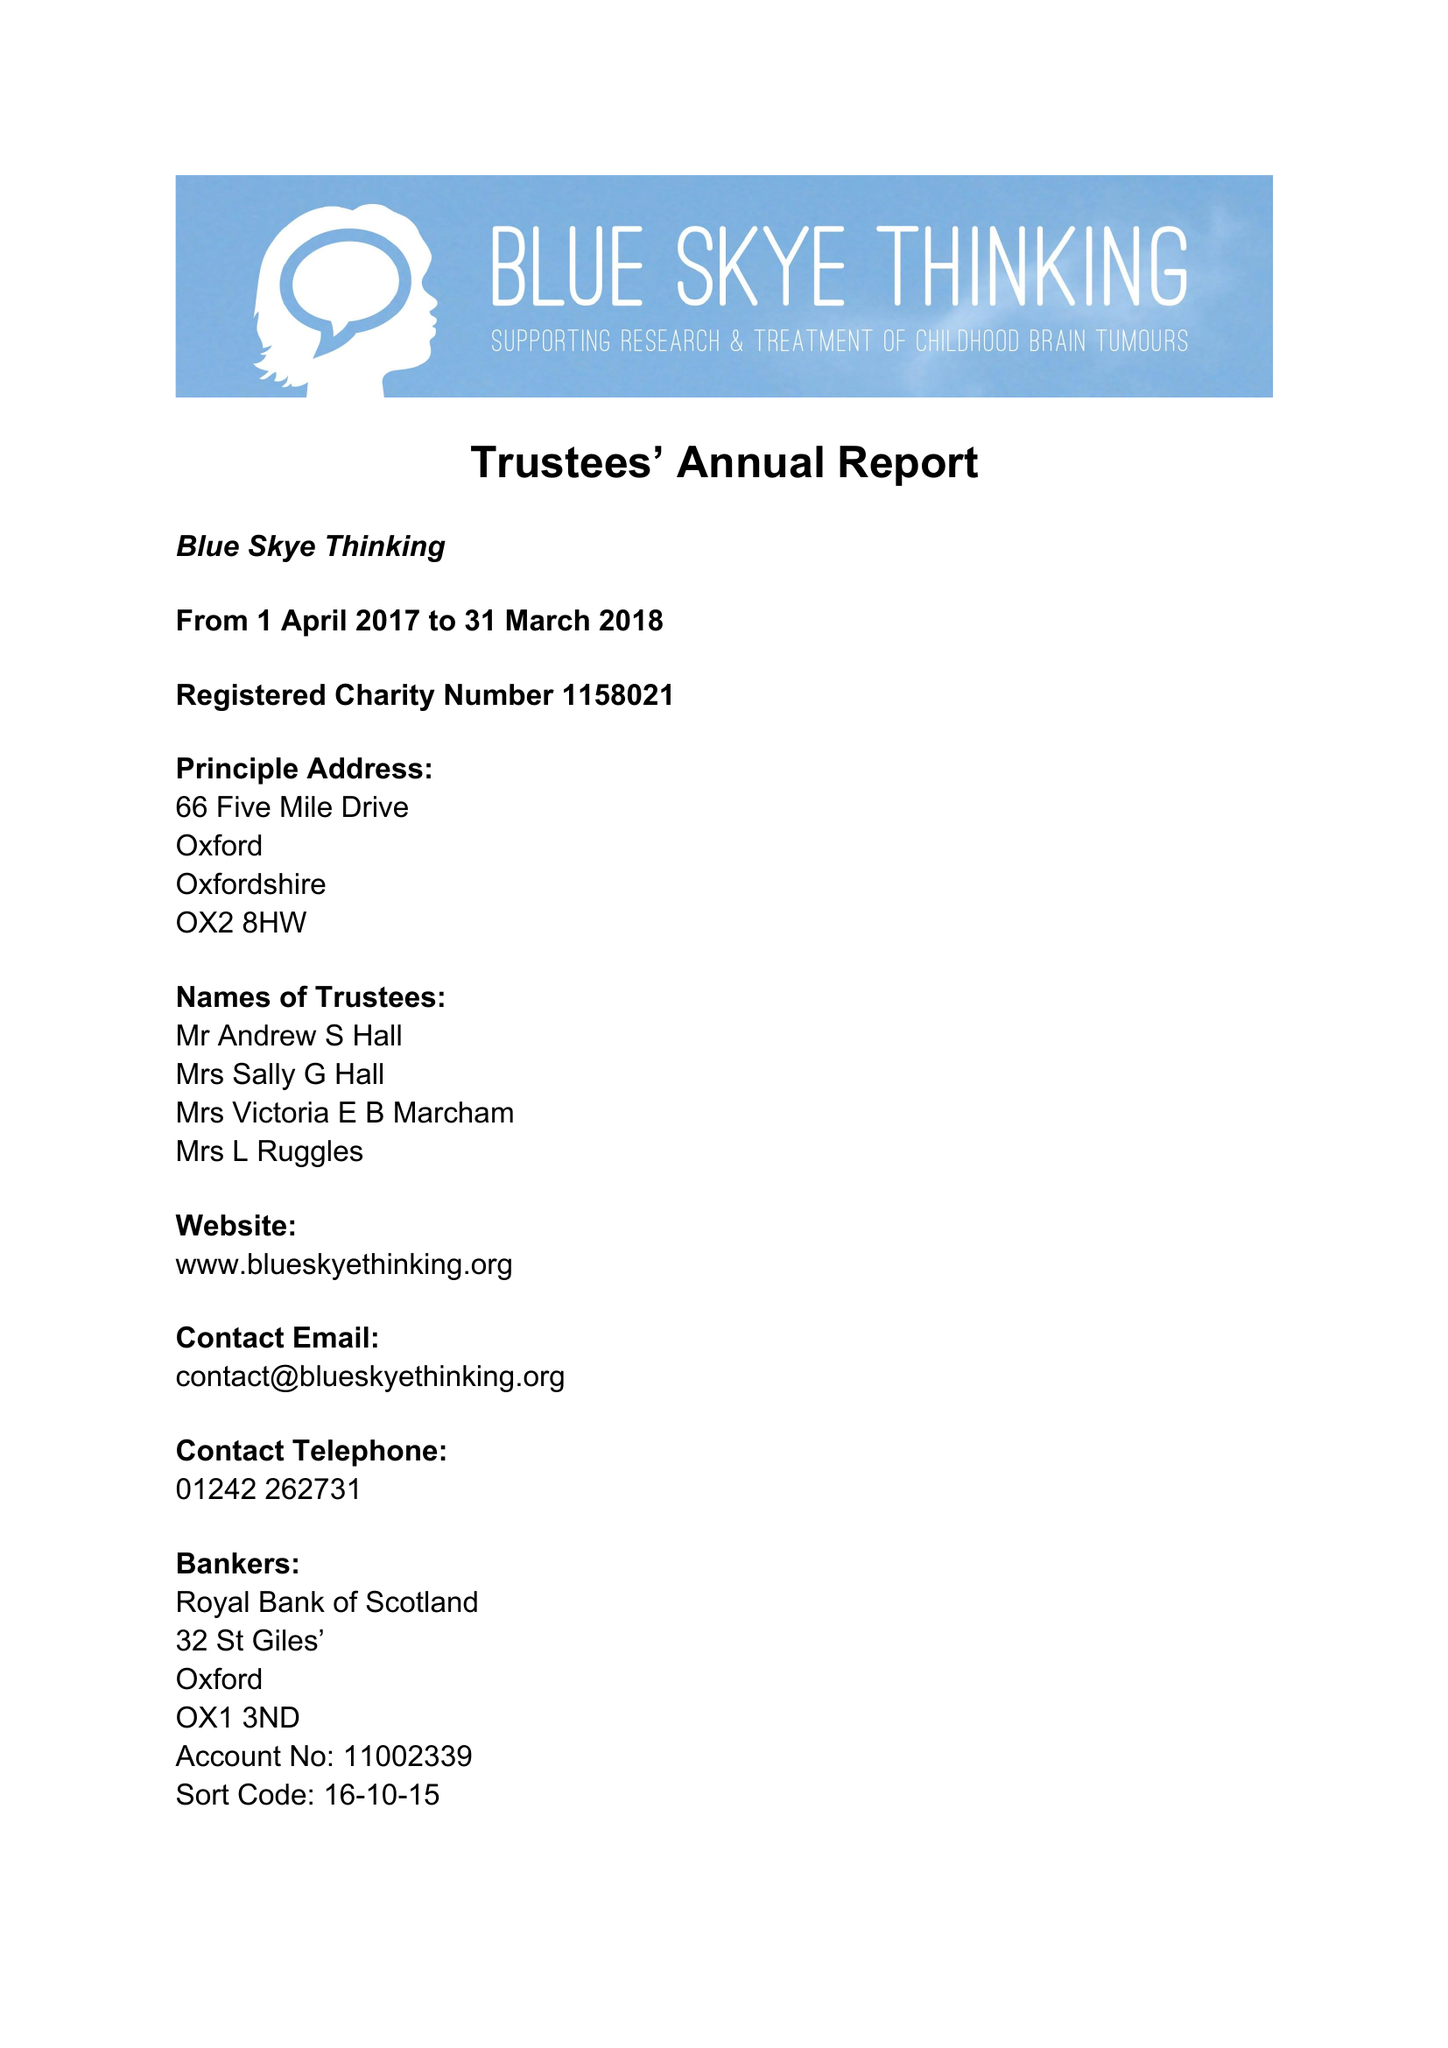What is the value for the charity_number?
Answer the question using a single word or phrase. 1158021 